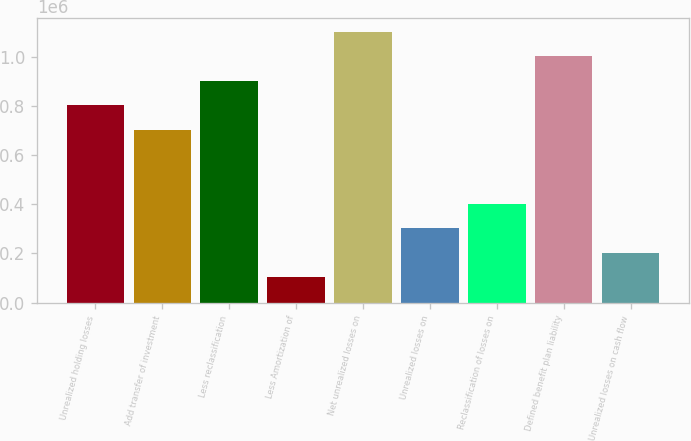<chart> <loc_0><loc_0><loc_500><loc_500><bar_chart><fcel>Unrealized holding losses<fcel>Add transfer of investment<fcel>Less reclassification<fcel>Less Amortization of<fcel>Net unrealized losses on<fcel>Unrealized losses on<fcel>Reclassification of losses on<fcel>Defined benefit plan liability<fcel>Unrealized losses on cash flow<nl><fcel>801647<fcel>701762<fcel>901532<fcel>102451<fcel>1.1013e+06<fcel>302221<fcel>402106<fcel>1.00142e+06<fcel>202336<nl></chart> 